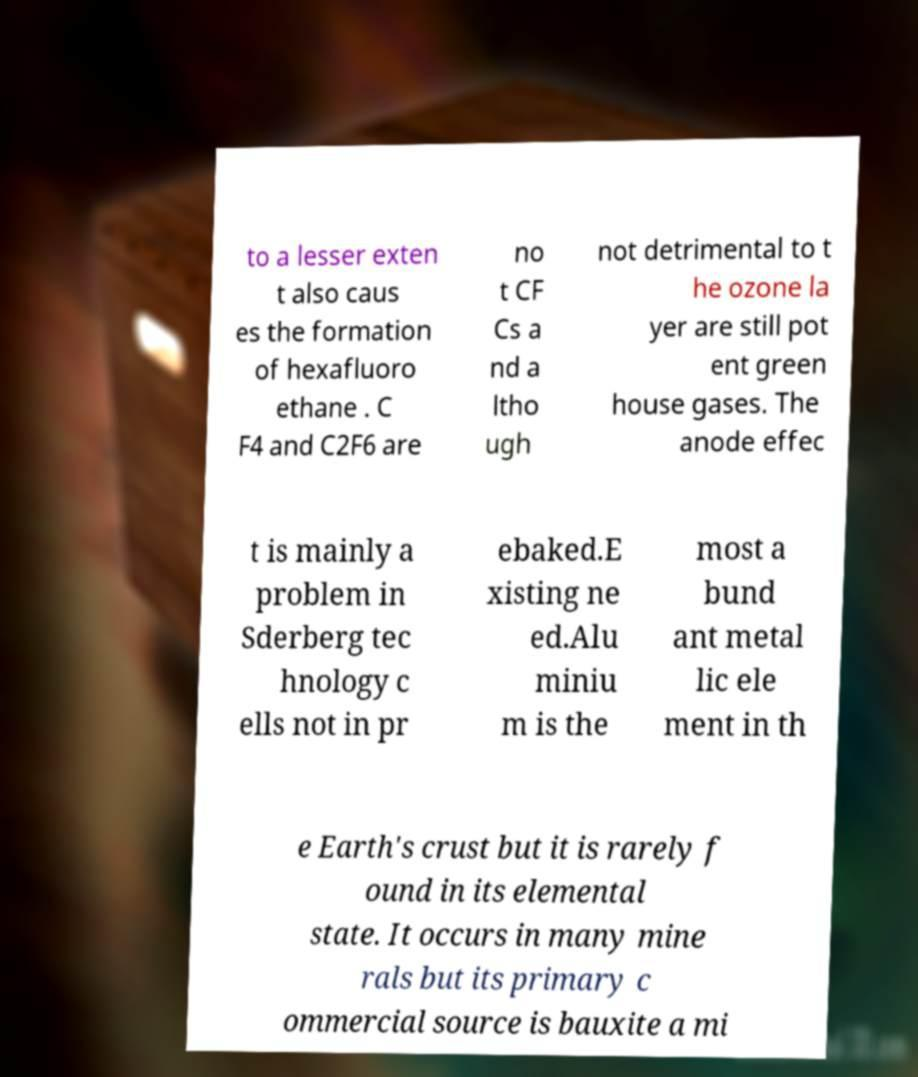Could you assist in decoding the text presented in this image and type it out clearly? to a lesser exten t also caus es the formation of hexafluoro ethane . C F4 and C2F6 are no t CF Cs a nd a ltho ugh not detrimental to t he ozone la yer are still pot ent green house gases. The anode effec t is mainly a problem in Sderberg tec hnology c ells not in pr ebaked.E xisting ne ed.Alu miniu m is the most a bund ant metal lic ele ment in th e Earth's crust but it is rarely f ound in its elemental state. It occurs in many mine rals but its primary c ommercial source is bauxite a mi 